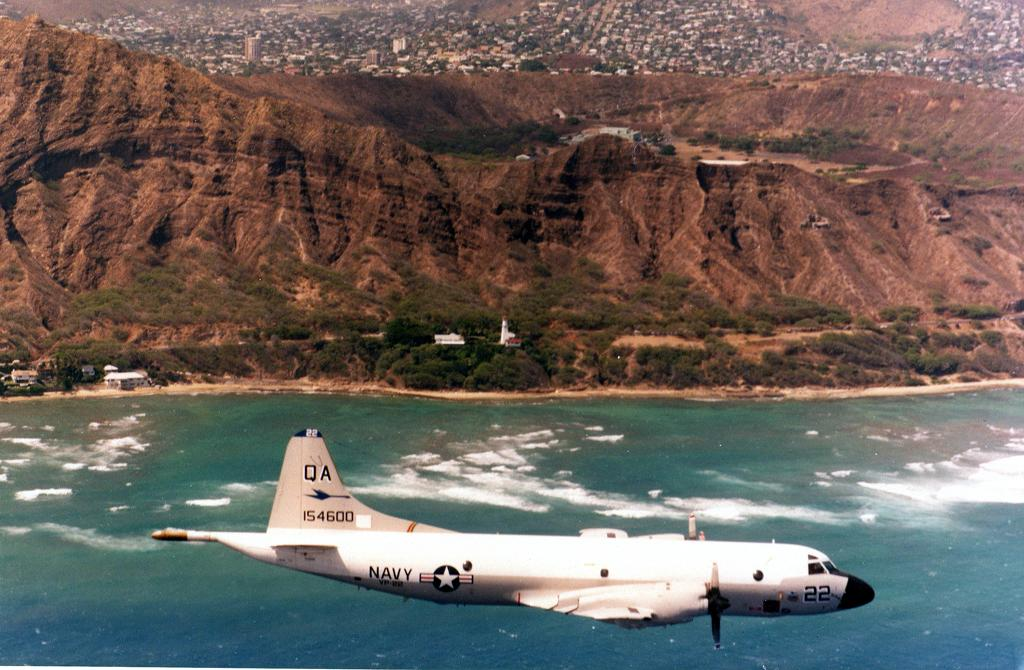<image>
Render a clear and concise summary of the photo. The airplane has a serial number "154600" painted onto its tail. 